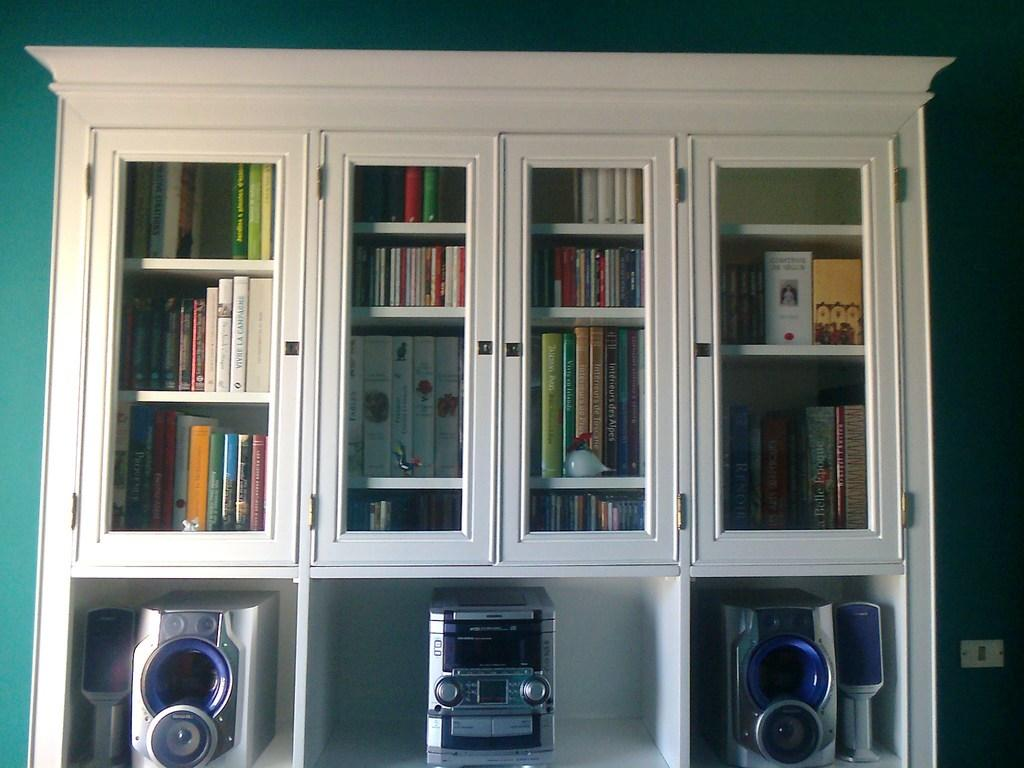Provide a one-sentence caption for the provided image. A white book shelf is full of books such as Vive le Champagne and a stereo set at the lower part of the shelf. 